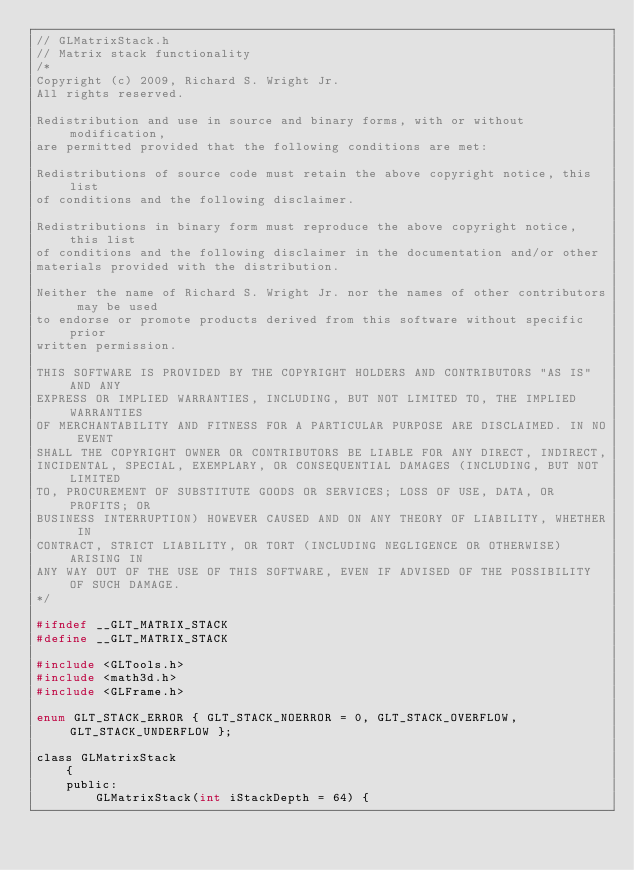<code> <loc_0><loc_0><loc_500><loc_500><_C_>// GLMatrixStack.h
// Matrix stack functionality
/*
Copyright (c) 2009, Richard S. Wright Jr.
All rights reserved.

Redistribution and use in source and binary forms, with or without modification, 
are permitted provided that the following conditions are met:

Redistributions of source code must retain the above copyright notice, this list 
of conditions and the following disclaimer.

Redistributions in binary form must reproduce the above copyright notice, this list 
of conditions and the following disclaimer in the documentation and/or other 
materials provided with the distribution.

Neither the name of Richard S. Wright Jr. nor the names of other contributors may be used 
to endorse or promote products derived from this software without specific prior 
written permission.

THIS SOFTWARE IS PROVIDED BY THE COPYRIGHT HOLDERS AND CONTRIBUTORS "AS IS" AND ANY 
EXPRESS OR IMPLIED WARRANTIES, INCLUDING, BUT NOT LIMITED TO, THE IMPLIED WARRANTIES 
OF MERCHANTABILITY AND FITNESS FOR A PARTICULAR PURPOSE ARE DISCLAIMED. IN NO EVENT 
SHALL THE COPYRIGHT OWNER OR CONTRIBUTORS BE LIABLE FOR ANY DIRECT, INDIRECT, 
INCIDENTAL, SPECIAL, EXEMPLARY, OR CONSEQUENTIAL DAMAGES (INCLUDING, BUT NOT LIMITED 
TO, PROCUREMENT OF SUBSTITUTE GOODS OR SERVICES; LOSS OF USE, DATA, OR PROFITS; OR 
BUSINESS INTERRUPTION) HOWEVER CAUSED AND ON ANY THEORY OF LIABILITY, WHETHER IN 
CONTRACT, STRICT LIABILITY, OR TORT (INCLUDING NEGLIGENCE OR OTHERWISE) ARISING IN 
ANY WAY OUT OF THE USE OF THIS SOFTWARE, EVEN IF ADVISED OF THE POSSIBILITY OF SUCH DAMAGE.
*/

#ifndef __GLT_MATRIX_STACK
#define __GLT_MATRIX_STACK

#include <GLTools.h>
#include <math3d.h>
#include <GLFrame.h>

enum GLT_STACK_ERROR { GLT_STACK_NOERROR = 0, GLT_STACK_OVERFLOW, GLT_STACK_UNDERFLOW }; 

class GLMatrixStack
	{
	public:
		GLMatrixStack(int iStackDepth = 64) {</code> 